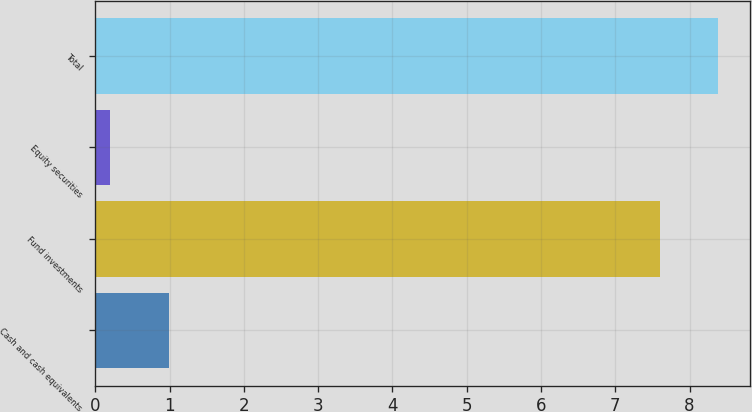<chart> <loc_0><loc_0><loc_500><loc_500><bar_chart><fcel>Cash and cash equivalents<fcel>Fund investments<fcel>Equity securities<fcel>Total<nl><fcel>0.99<fcel>7.6<fcel>0.2<fcel>8.39<nl></chart> 